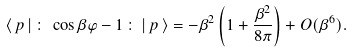Convert formula to latex. <formula><loc_0><loc_0><loc_500><loc_500>\langle \, p \, | \, \colon \, \cos \beta \varphi - 1 \, \colon \, | \, p \, \rangle = - \beta ^ { 2 } \left ( 1 + \frac { \beta ^ { 2 } } { 8 \pi } \right ) + O ( \beta ^ { 6 } ) .</formula> 